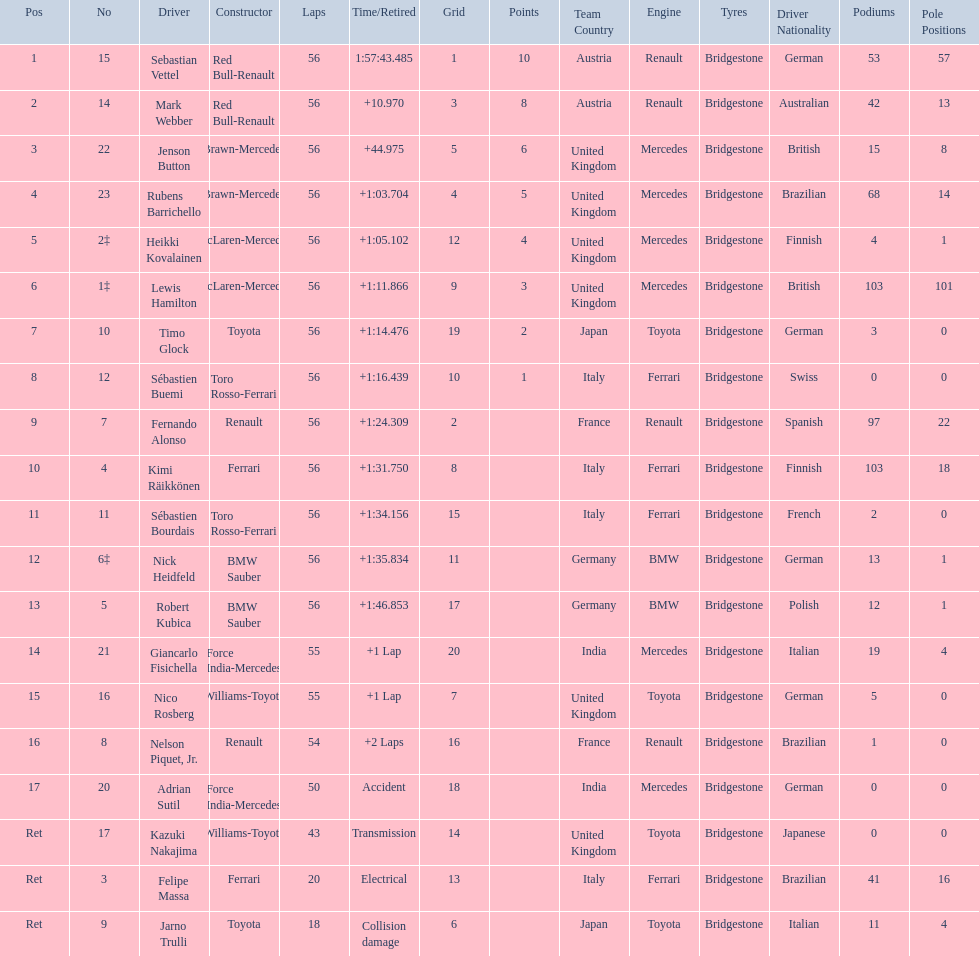Which drivers raced in the 2009 chinese grand prix? Sebastian Vettel, Mark Webber, Jenson Button, Rubens Barrichello, Heikki Kovalainen, Lewis Hamilton, Timo Glock, Sébastien Buemi, Fernando Alonso, Kimi Räikkönen, Sébastien Bourdais, Nick Heidfeld, Robert Kubica, Giancarlo Fisichella, Nico Rosberg, Nelson Piquet, Jr., Adrian Sutil, Kazuki Nakajima, Felipe Massa, Jarno Trulli. Of the drivers in the 2009 chinese grand prix, which finished the race? Sebastian Vettel, Mark Webber, Jenson Button, Rubens Barrichello, Heikki Kovalainen, Lewis Hamilton, Timo Glock, Sébastien Buemi, Fernando Alonso, Kimi Räikkönen, Sébastien Bourdais, Nick Heidfeld, Robert Kubica. Of the drivers who finished the race, who had the slowest time? Robert Kubica. 